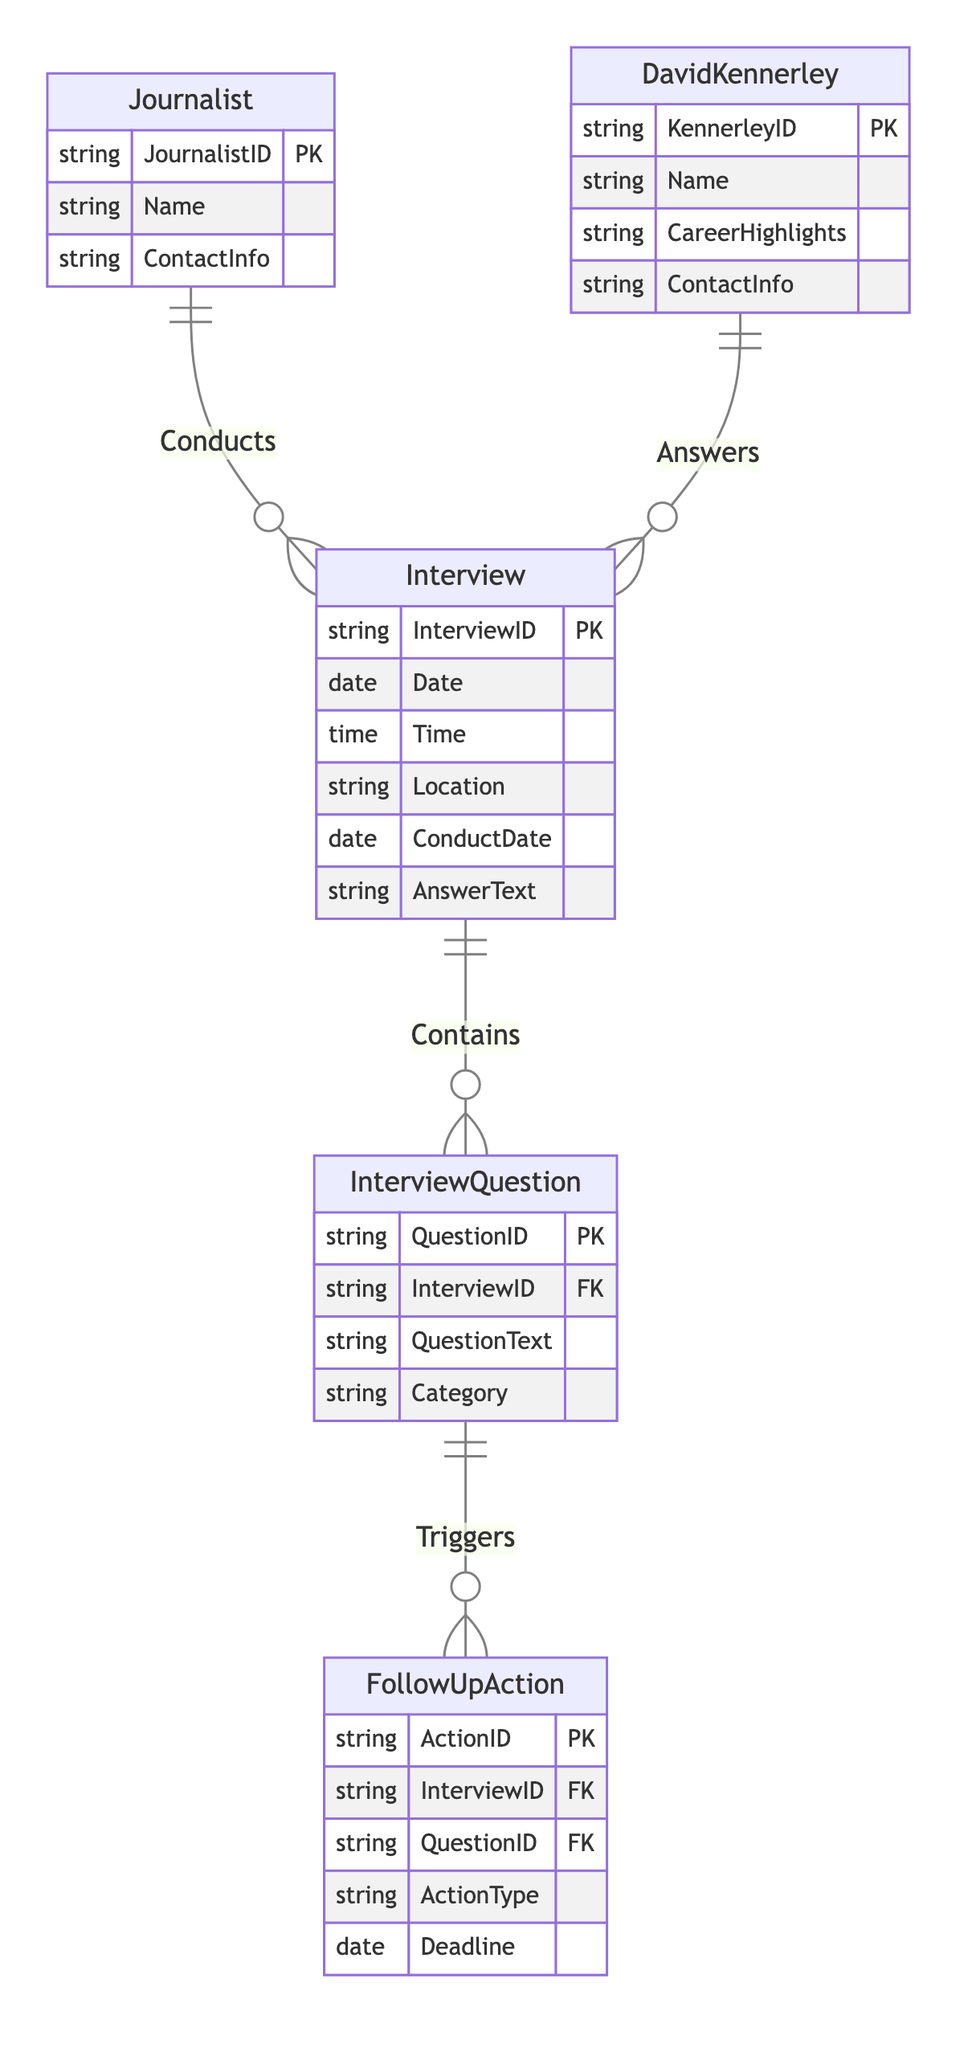What is the primary entity that conducts the interview? The diagram shows that the Journalist entity has a relationship called "Conducts" with the Interview entity, indicating that the Journalist is responsible for conducting the interview.
Answer: Journalist How many main entities are there in the diagram? By reviewing the diagram, we can count the distinct entities present: Journalist, Interview, InterviewQuestion, FollowUpAction, and DavidKennerley, resulting in a total of five main entities.
Answer: 5 What type of relationship exists between Interview and InterviewQuestion? The relationship between Interview and InterviewQuestion is labeled "Contains," indicating that each Interview can contain multiple InterviewQuestions, which is a common structure in interviews to have several questions asked.
Answer: Contains Which entity answers the interview questions? The relationship shown between DavidKennerley and Interview indicates that David Kennerley is the one who answers the interview questions during an Interview.
Answer: DavidKennerley What is the cardinality of the relationship between InterviewQuestion and FollowUpAction? The diagram shows that the cardinality of the relationship labeled "Triggers" between InterviewQuestion and FollowUpAction is "1:N," meaning one InterviewQuestion can lead to multiple FollowUpActions being generated.
Answer: 1:N How many attributes does the Interview entity have? By inspecting the Interview entity in the diagram, we can see it has four attributes listed: InterviewID, Date, Time, and Location, revealing the details recorded for each interview.
Answer: 4 What attribute connects the Interview to the FollowUpAction? The diagram shows that the FollowUpAction is connected to Interview through the InterviewID attribute, making it clear that the FollowUpActions are linked specifically to the Interview being conducted.
Answer: InterviewID Which entity includes the attribute "CareerHighlights"? Looking at the diagram, we can see that the attribute "CareerHighlights" is specific to the DavidKennerley entity, which provides insight into his notable achievements.
Answer: DavidKennerley What action may be triggered by an InterviewQuestion? The diagram indicates that FollowUpAction is the entity that can be triggered by an InterviewQuestion, signifying further steps that can be taken based on the questions that are posed.
Answer: FollowUpAction 